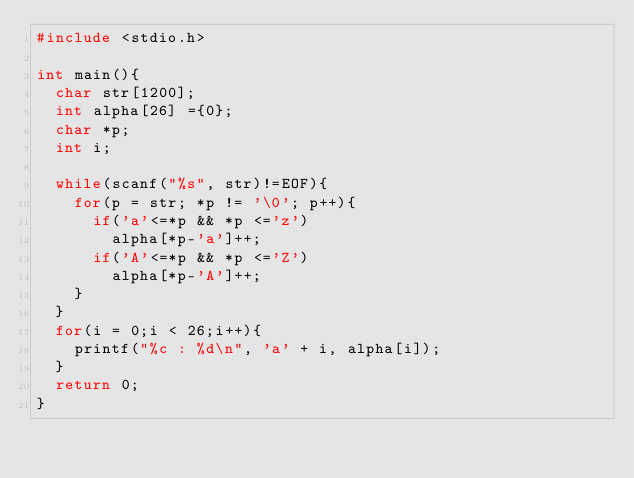Convert code to text. <code><loc_0><loc_0><loc_500><loc_500><_C_>#include <stdio.h>

int main(){
	char str[1200];
	int alpha[26] ={0};
	char *p;
	int i;

	while(scanf("%s", str)!=EOF){
		for(p = str; *p != '\0'; p++){
			if('a'<=*p && *p <='z')
				alpha[*p-'a']++;
			if('A'<=*p && *p <='Z')
				alpha[*p-'A']++;
		}
	}
	for(i = 0;i < 26;i++){
		printf("%c : %d\n", 'a' + i, alpha[i]);
	}
	return 0;
}</code> 